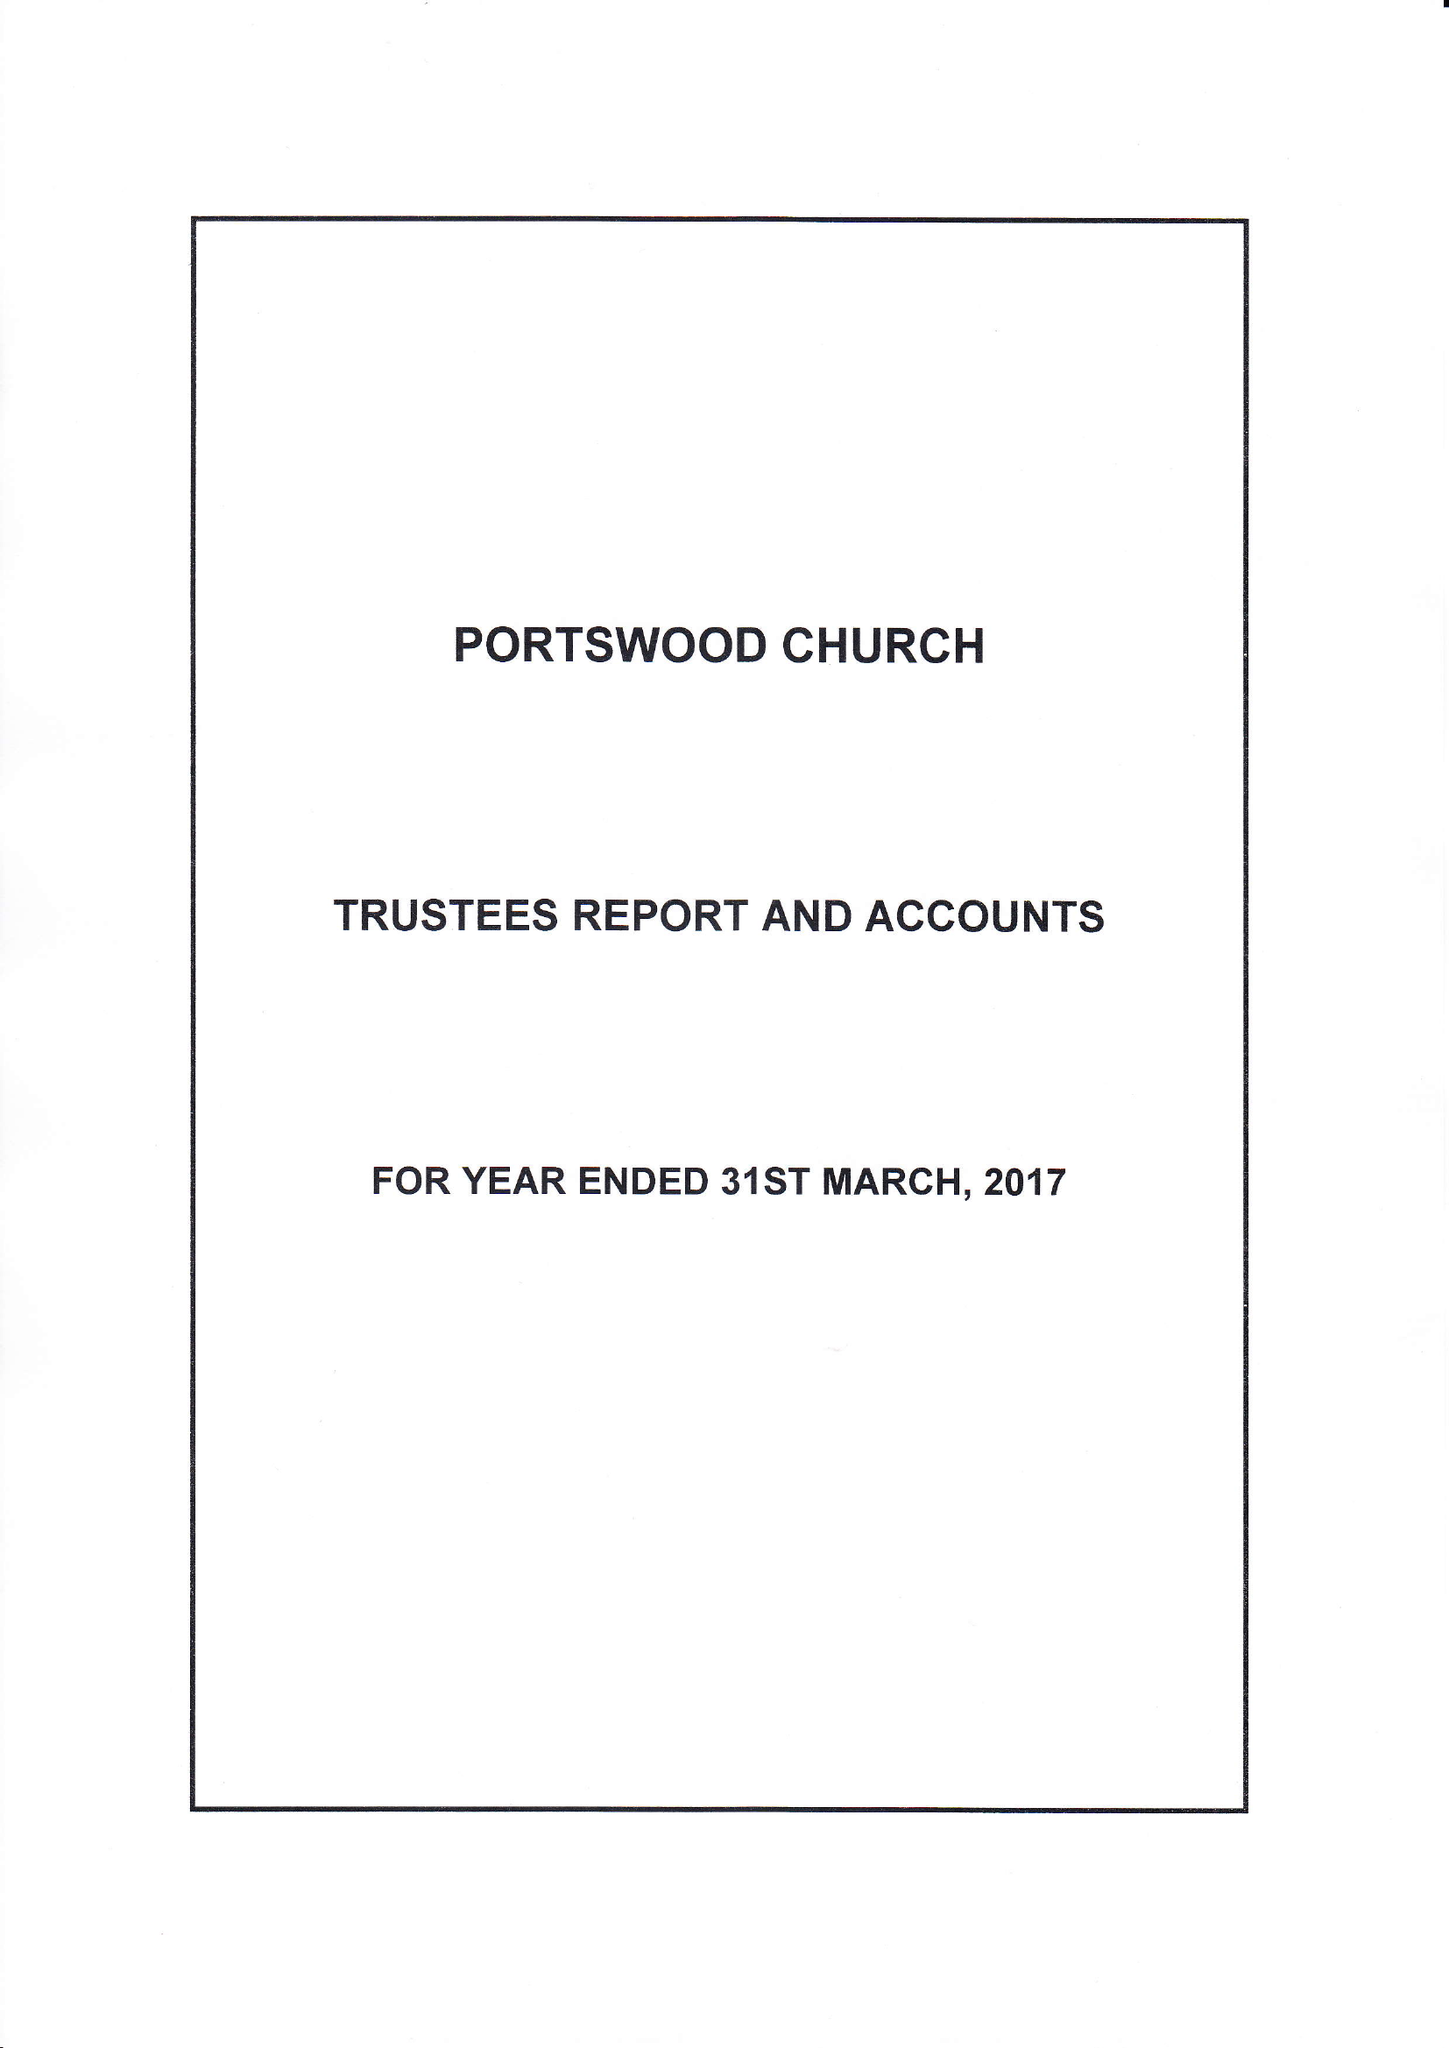What is the value for the spending_annually_in_british_pounds?
Answer the question using a single word or phrase. 299325.00 